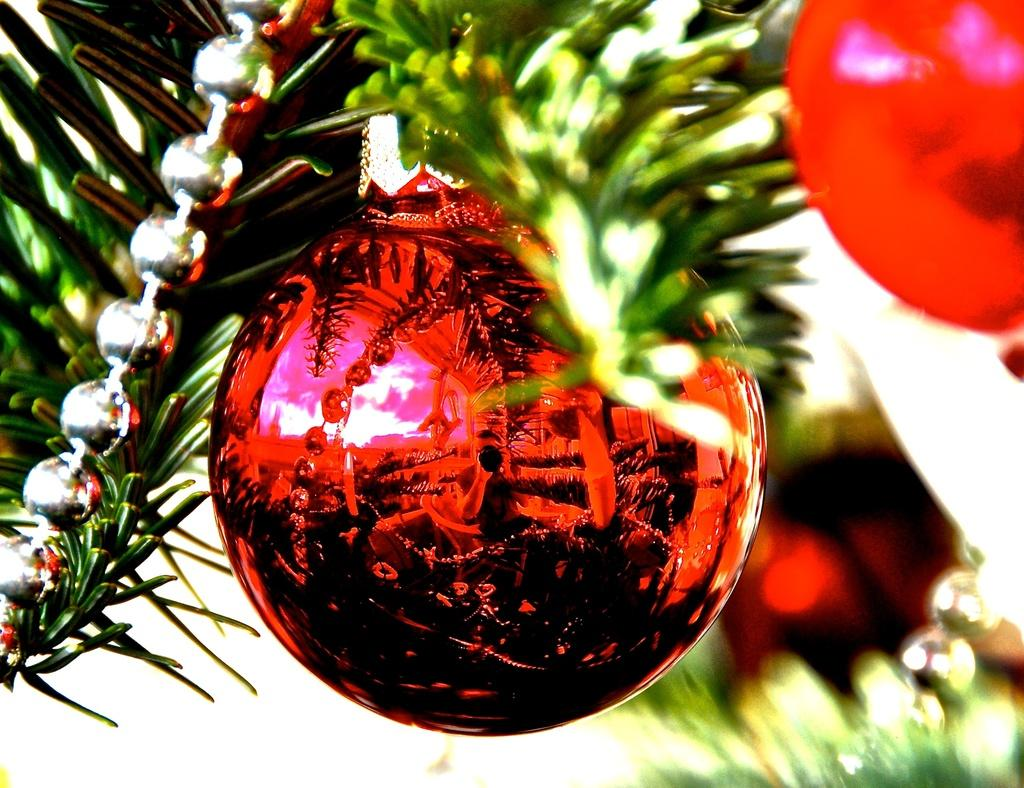What is the color of the decorative ball in the image? The decorative ball in the image is red. What can be seen on the surface of the ball? The ball has reflections of other images on it. What types of decorative items are present in the image? There are decorative items like balls and leaves in the image. How would you describe the background of the image? The background of the image is blurred. What type of sweater is being worn by the horses in the image? There are no horses or sweaters present in the image; it features a red decorative ball with reflections and other decorative items. 